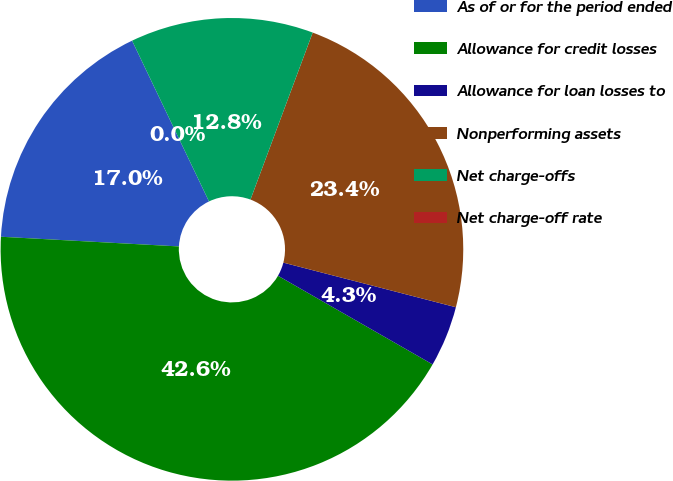<chart> <loc_0><loc_0><loc_500><loc_500><pie_chart><fcel>As of or for the period ended<fcel>Allowance for credit losses<fcel>Allowance for loan losses to<fcel>Nonperforming assets<fcel>Net charge-offs<fcel>Net charge-off rate<nl><fcel>17.03%<fcel>42.58%<fcel>4.26%<fcel>23.35%<fcel>12.78%<fcel>0.0%<nl></chart> 